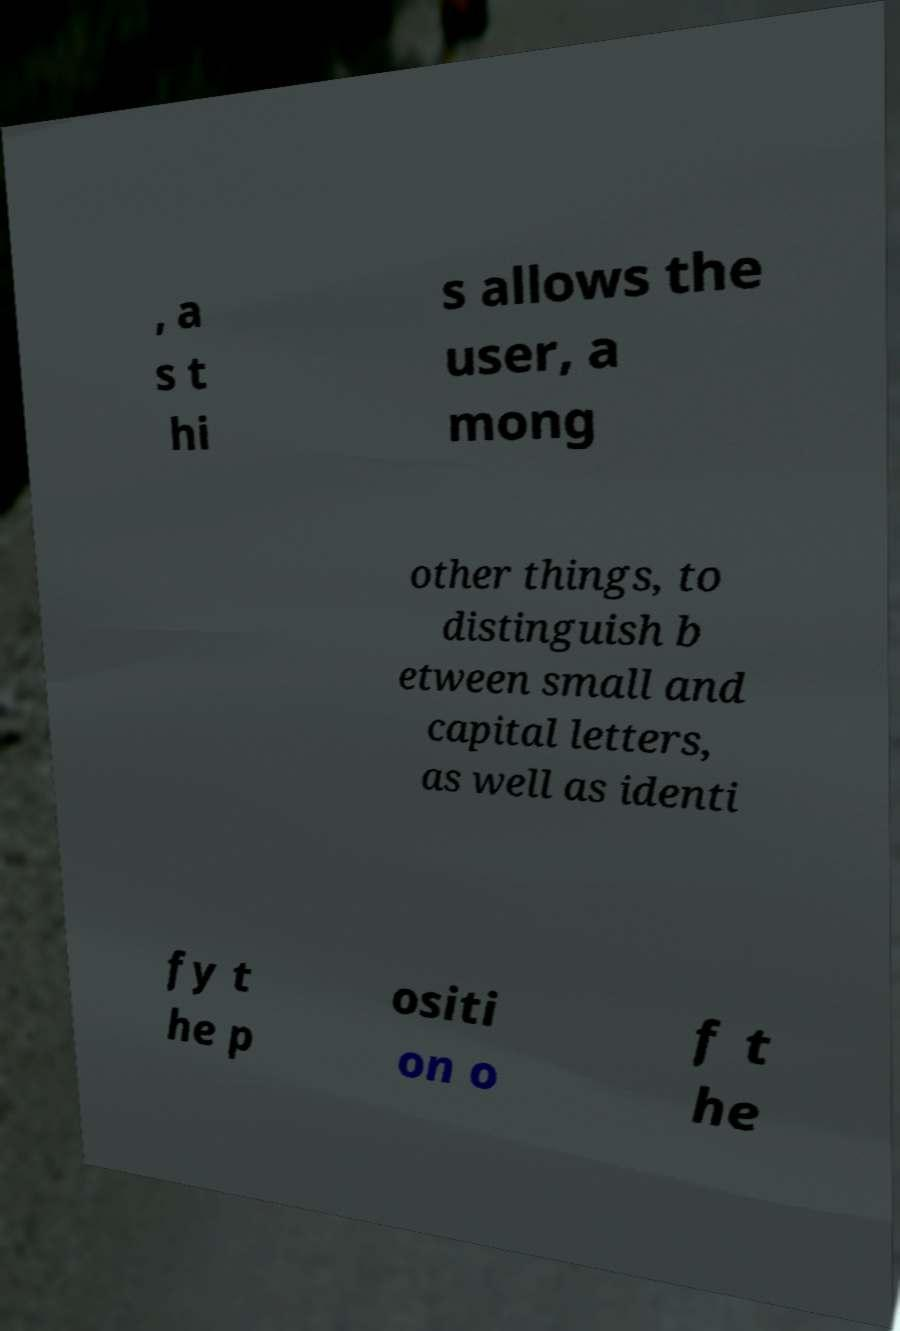Please read and relay the text visible in this image. What does it say? , a s t hi s allows the user, a mong other things, to distinguish b etween small and capital letters, as well as identi fy t he p ositi on o f t he 